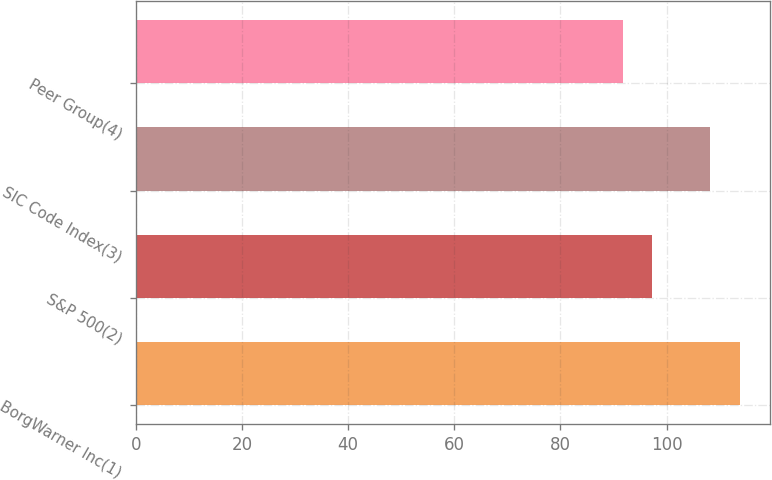Convert chart to OTSL. <chart><loc_0><loc_0><loc_500><loc_500><bar_chart><fcel>BorgWarner Inc(1)<fcel>S&P 500(2)<fcel>SIC Code Index(3)<fcel>Peer Group(4)<nl><fcel>113.86<fcel>97.33<fcel>108.22<fcel>91.74<nl></chart> 